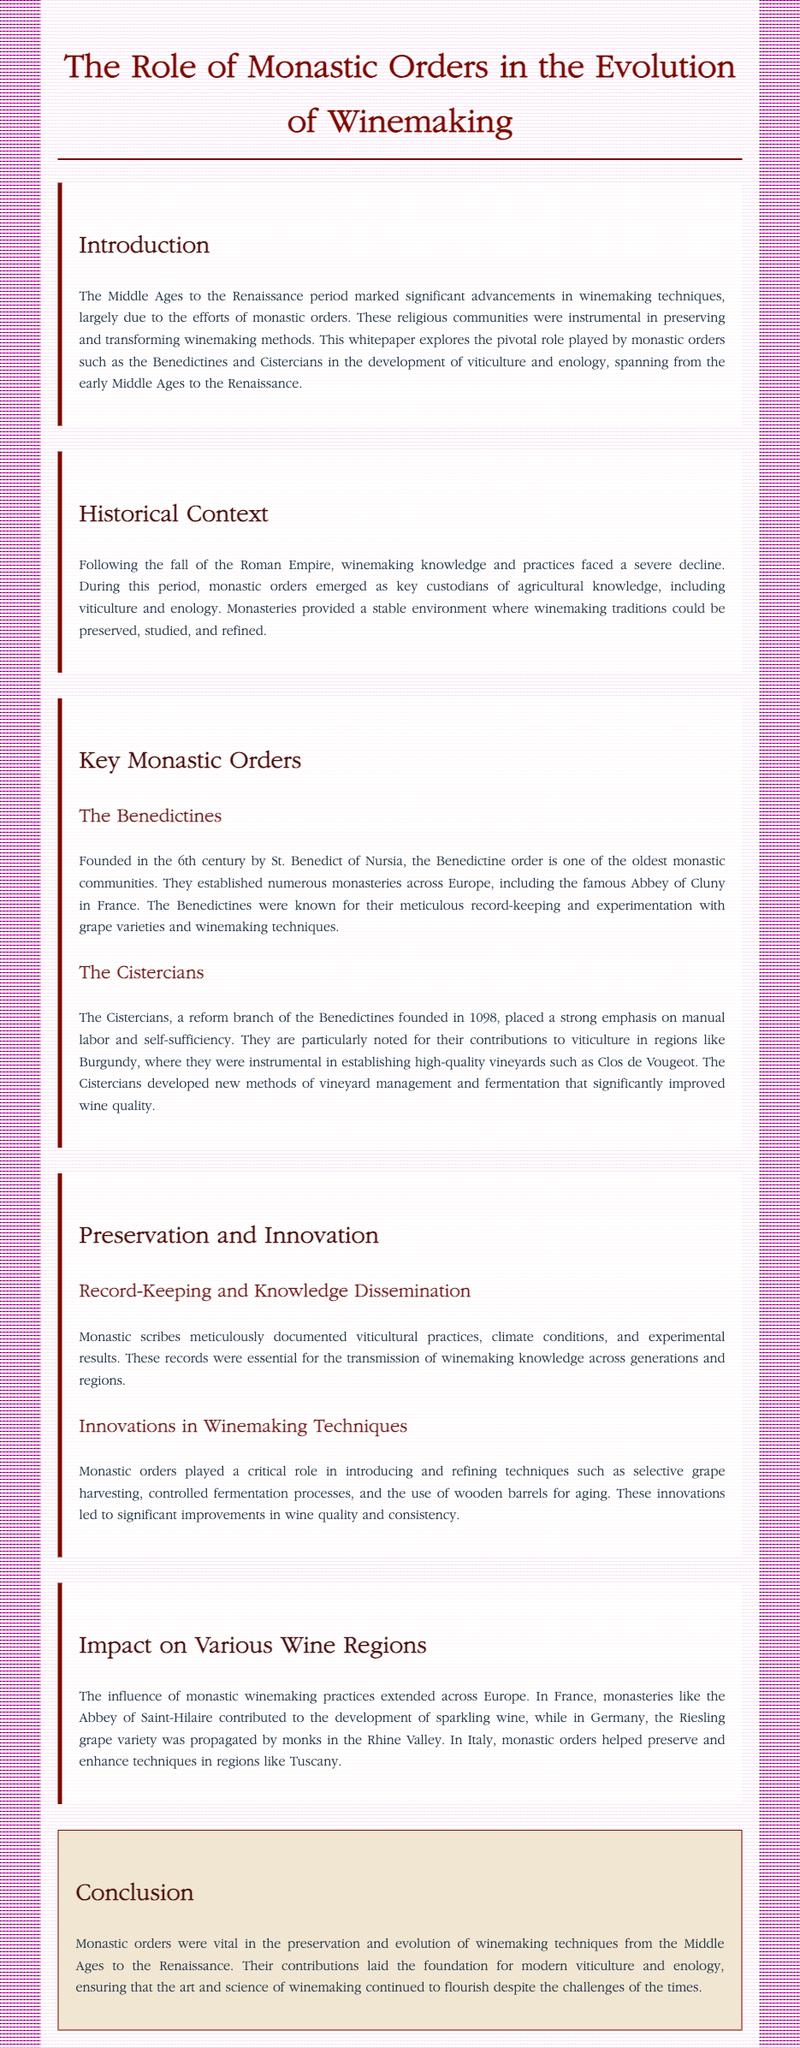What were the names of the key monastic orders discussed? The document highlights the Benedictines and Cistercians as key monastic orders.
Answer: Benedictines and Cistercians In which century was the Benedictine order founded? The text states that the Benedictine order was founded in the 6th century.
Answer: 6th century What wine region is notably associated with the Cistercians? The document mentions that the Cistercians were particularly noted for their contributions to Burgundy.
Answer: Burgundy What specific innovation did monastic orders introduce for aging wine? According to the document, monastic orders developed the use of wooden barrels for aging wine.
Answer: Wooden barrels What major contribution did monastic scribes provide to winemaking? The document states that monastic scribes documented viticultural practices, essential for knowledge transmission.
Answer: Documentation How did monastic orders influence wine quality? The text explains that innovations introduced by monastic orders significantly improved wine quality and consistency.
Answer: Improved quality and consistency Which grape variety was propagated by monks in Germany? The document specifies that the Riesling grape variety was propagated by monks in the Rhine Valley.
Answer: Riesling What was the central role of monasteries during the decline of winemaking knowledge? The document describes monasteries as key custodians of agricultural knowledge during this period.
Answer: Custodians of knowledge What is the main conclusion of the whitepaper? The conclusion states that monastic orders laid the foundation for modern viticulture and enology.
Answer: Foundation for modern viticulture and enology 